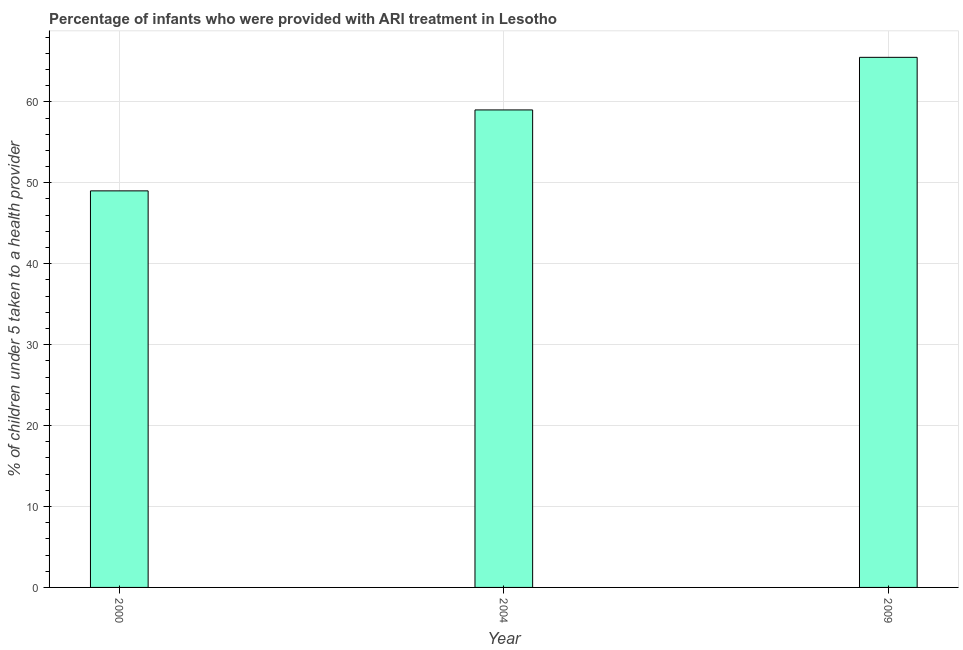What is the title of the graph?
Provide a short and direct response. Percentage of infants who were provided with ARI treatment in Lesotho. What is the label or title of the Y-axis?
Your answer should be very brief. % of children under 5 taken to a health provider. What is the percentage of children who were provided with ari treatment in 2009?
Provide a succinct answer. 65.5. Across all years, what is the maximum percentage of children who were provided with ari treatment?
Your answer should be compact. 65.5. Across all years, what is the minimum percentage of children who were provided with ari treatment?
Provide a short and direct response. 49. In which year was the percentage of children who were provided with ari treatment minimum?
Keep it short and to the point. 2000. What is the sum of the percentage of children who were provided with ari treatment?
Provide a succinct answer. 173.5. What is the difference between the percentage of children who were provided with ari treatment in 2000 and 2009?
Provide a short and direct response. -16.5. What is the average percentage of children who were provided with ari treatment per year?
Ensure brevity in your answer.  57.83. In how many years, is the percentage of children who were provided with ari treatment greater than 24 %?
Provide a short and direct response. 3. Do a majority of the years between 2000 and 2004 (inclusive) have percentage of children who were provided with ari treatment greater than 58 %?
Provide a short and direct response. No. What is the ratio of the percentage of children who were provided with ari treatment in 2004 to that in 2009?
Your answer should be compact. 0.9. Is the difference between the percentage of children who were provided with ari treatment in 2000 and 2009 greater than the difference between any two years?
Your response must be concise. Yes. What is the difference between the highest and the second highest percentage of children who were provided with ari treatment?
Your answer should be compact. 6.5. Is the sum of the percentage of children who were provided with ari treatment in 2000 and 2009 greater than the maximum percentage of children who were provided with ari treatment across all years?
Your answer should be very brief. Yes. What is the difference between the highest and the lowest percentage of children who were provided with ari treatment?
Your response must be concise. 16.5. How many bars are there?
Ensure brevity in your answer.  3. Are the values on the major ticks of Y-axis written in scientific E-notation?
Your answer should be very brief. No. What is the % of children under 5 taken to a health provider of 2000?
Give a very brief answer. 49. What is the % of children under 5 taken to a health provider in 2009?
Ensure brevity in your answer.  65.5. What is the difference between the % of children under 5 taken to a health provider in 2000 and 2004?
Keep it short and to the point. -10. What is the difference between the % of children under 5 taken to a health provider in 2000 and 2009?
Ensure brevity in your answer.  -16.5. What is the ratio of the % of children under 5 taken to a health provider in 2000 to that in 2004?
Your answer should be very brief. 0.83. What is the ratio of the % of children under 5 taken to a health provider in 2000 to that in 2009?
Keep it short and to the point. 0.75. What is the ratio of the % of children under 5 taken to a health provider in 2004 to that in 2009?
Provide a succinct answer. 0.9. 